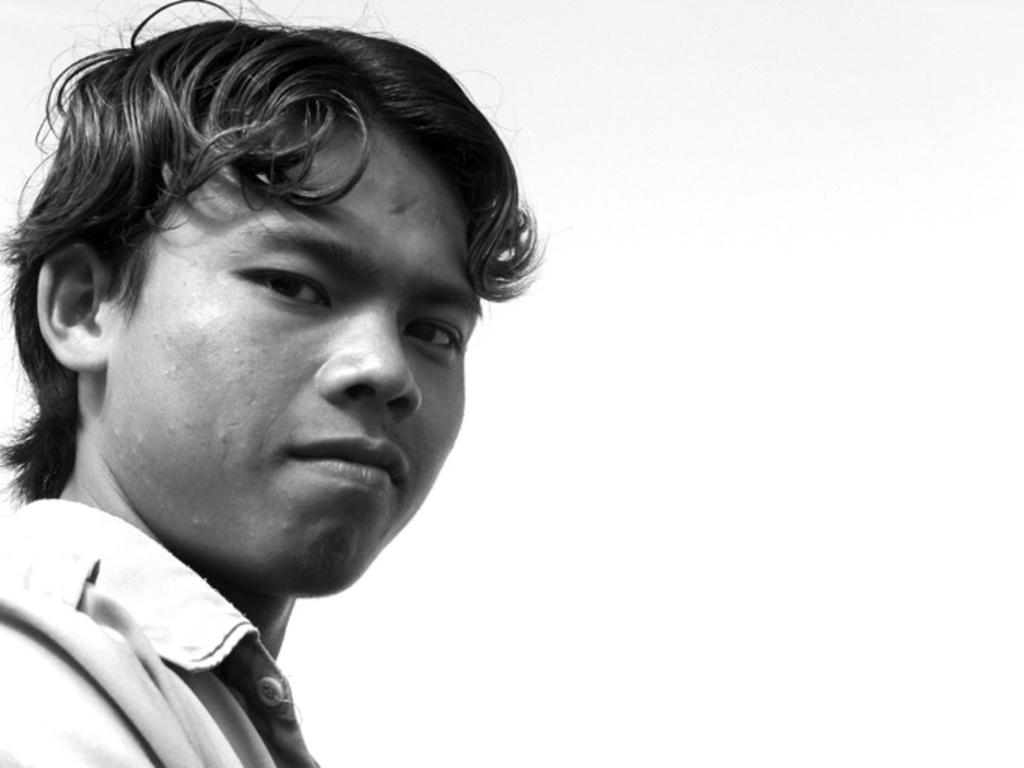What is the color scheme of the image? The image is black and white. Can you describe the main subject in the image? There is a man in the image. What type of vessel is the man using in the image? There is no vessel present in the image; it is a black and white image of a man. How many seats can be seen in the image? There are no seats visible in the image, as it only features a man in a black and white setting. 